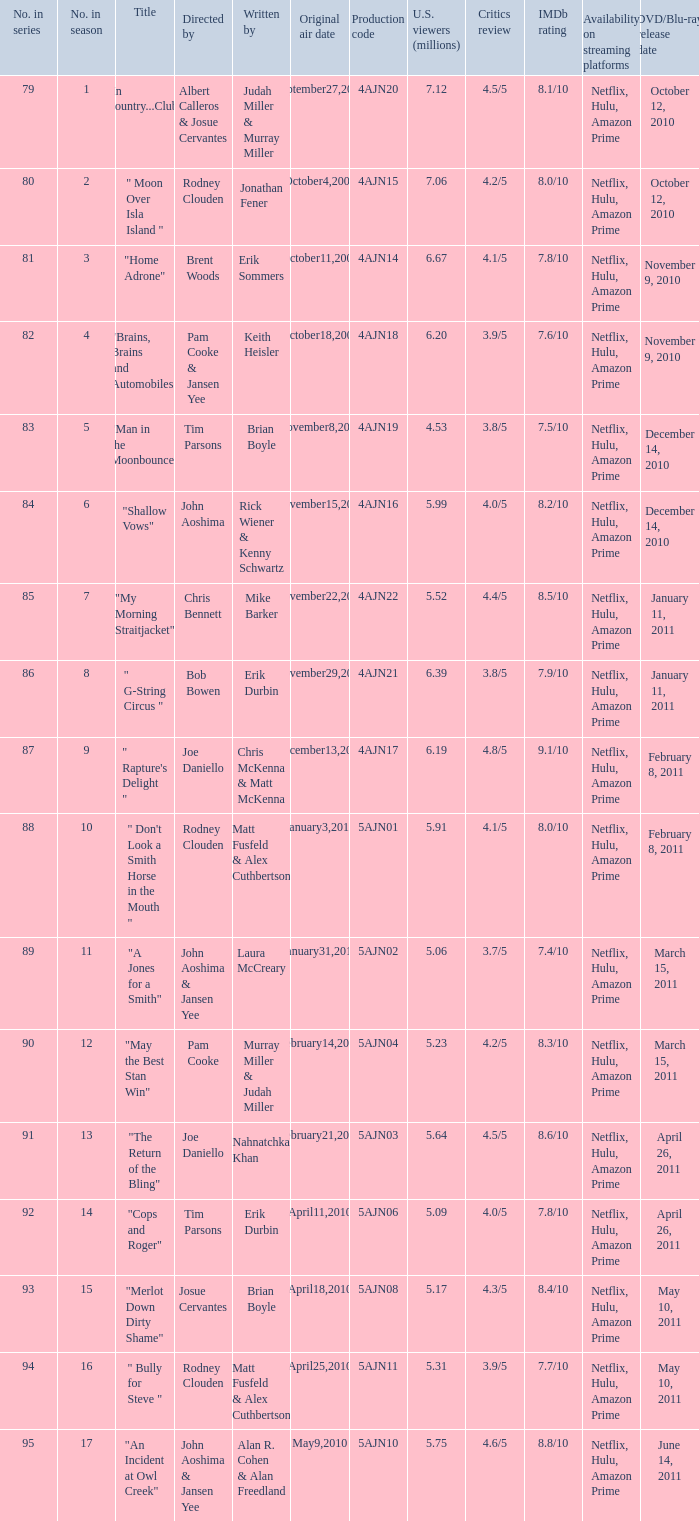Name who wrote number 88 Matt Fusfeld & Alex Cuthbertson. 